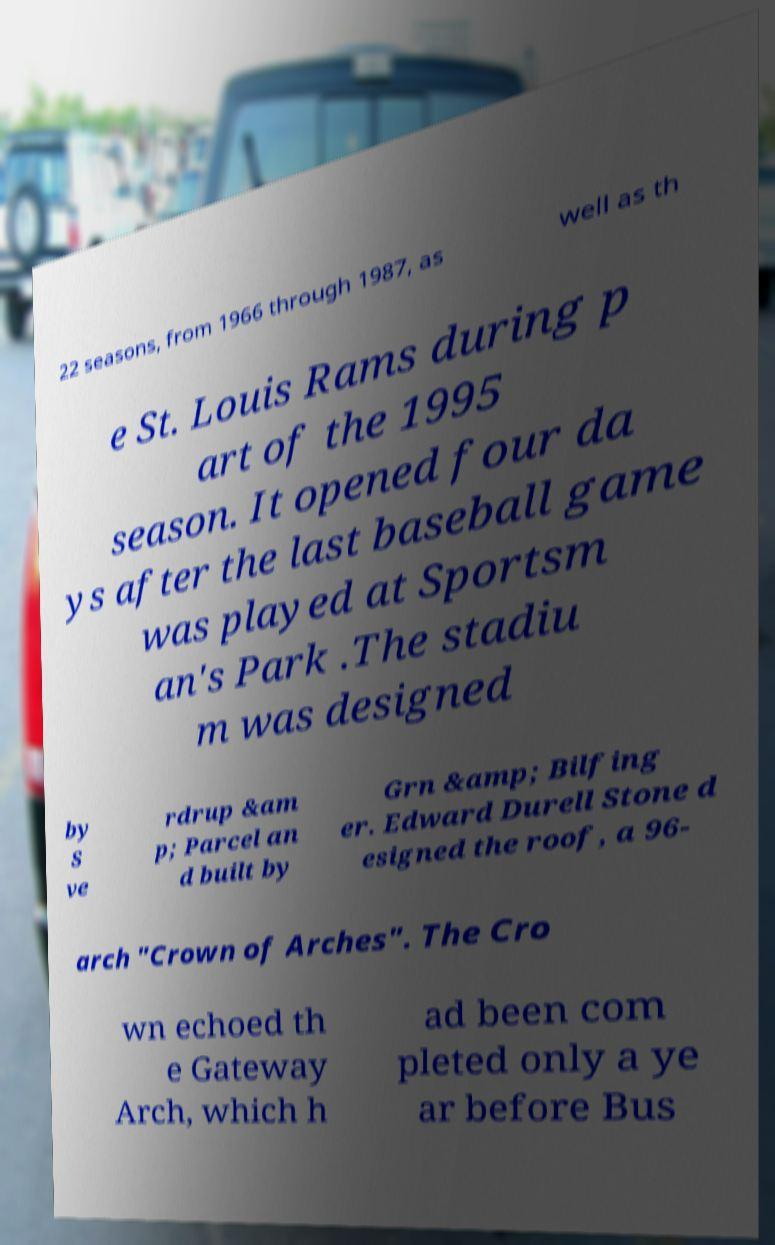There's text embedded in this image that I need extracted. Can you transcribe it verbatim? 22 seasons, from 1966 through 1987, as well as th e St. Louis Rams during p art of the 1995 season. It opened four da ys after the last baseball game was played at Sportsm an's Park .The stadiu m was designed by S ve rdrup &am p; Parcel an d built by Grn &amp; Bilfing er. Edward Durell Stone d esigned the roof, a 96- arch "Crown of Arches". The Cro wn echoed th e Gateway Arch, which h ad been com pleted only a ye ar before Bus 